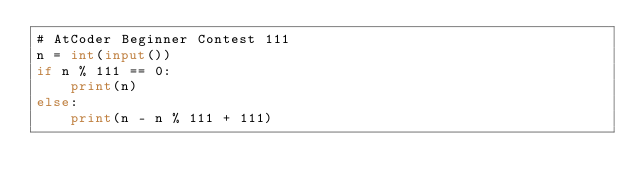<code> <loc_0><loc_0><loc_500><loc_500><_Python_># AtCoder Beginner Contest 111
n = int(input())
if n % 111 == 0:
    print(n)
else:
    print(n - n % 111 + 111)
</code> 